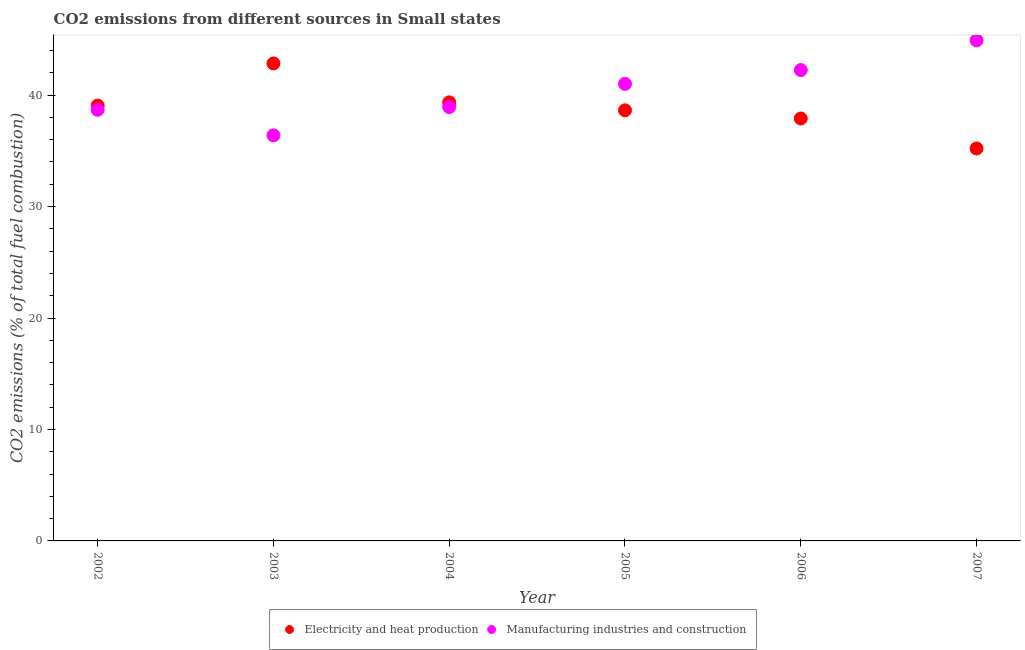What is the co2 emissions due to electricity and heat production in 2004?
Keep it short and to the point. 39.35. Across all years, what is the maximum co2 emissions due to manufacturing industries?
Offer a very short reply. 44.92. Across all years, what is the minimum co2 emissions due to manufacturing industries?
Give a very brief answer. 36.39. In which year was the co2 emissions due to manufacturing industries minimum?
Ensure brevity in your answer.  2003. What is the total co2 emissions due to manufacturing industries in the graph?
Provide a succinct answer. 242.19. What is the difference between the co2 emissions due to manufacturing industries in 2006 and that in 2007?
Keep it short and to the point. -2.67. What is the difference between the co2 emissions due to manufacturing industries in 2003 and the co2 emissions due to electricity and heat production in 2006?
Provide a short and direct response. -1.51. What is the average co2 emissions due to manufacturing industries per year?
Your answer should be very brief. 40.36. In the year 2006, what is the difference between the co2 emissions due to manufacturing industries and co2 emissions due to electricity and heat production?
Ensure brevity in your answer.  4.35. What is the ratio of the co2 emissions due to electricity and heat production in 2003 to that in 2005?
Your response must be concise. 1.11. Is the co2 emissions due to electricity and heat production in 2004 less than that in 2007?
Offer a very short reply. No. Is the difference between the co2 emissions due to manufacturing industries in 2005 and 2006 greater than the difference between the co2 emissions due to electricity and heat production in 2005 and 2006?
Give a very brief answer. No. What is the difference between the highest and the second highest co2 emissions due to electricity and heat production?
Make the answer very short. 3.49. What is the difference between the highest and the lowest co2 emissions due to electricity and heat production?
Your response must be concise. 7.63. Is the sum of the co2 emissions due to electricity and heat production in 2003 and 2004 greater than the maximum co2 emissions due to manufacturing industries across all years?
Your answer should be compact. Yes. Does the co2 emissions due to manufacturing industries monotonically increase over the years?
Provide a short and direct response. No. Is the co2 emissions due to electricity and heat production strictly less than the co2 emissions due to manufacturing industries over the years?
Provide a succinct answer. No. How many years are there in the graph?
Your answer should be very brief. 6. What is the difference between two consecutive major ticks on the Y-axis?
Keep it short and to the point. 10. Are the values on the major ticks of Y-axis written in scientific E-notation?
Provide a short and direct response. No. Does the graph contain grids?
Your answer should be compact. No. Where does the legend appear in the graph?
Make the answer very short. Bottom center. How are the legend labels stacked?
Your answer should be very brief. Horizontal. What is the title of the graph?
Offer a terse response. CO2 emissions from different sources in Small states. What is the label or title of the X-axis?
Offer a terse response. Year. What is the label or title of the Y-axis?
Give a very brief answer. CO2 emissions (% of total fuel combustion). What is the CO2 emissions (% of total fuel combustion) in Electricity and heat production in 2002?
Make the answer very short. 39.06. What is the CO2 emissions (% of total fuel combustion) in Manufacturing industries and construction in 2002?
Your answer should be compact. 38.68. What is the CO2 emissions (% of total fuel combustion) in Electricity and heat production in 2003?
Keep it short and to the point. 42.84. What is the CO2 emissions (% of total fuel combustion) in Manufacturing industries and construction in 2003?
Give a very brief answer. 36.39. What is the CO2 emissions (% of total fuel combustion) in Electricity and heat production in 2004?
Offer a very short reply. 39.35. What is the CO2 emissions (% of total fuel combustion) of Manufacturing industries and construction in 2004?
Your answer should be very brief. 38.93. What is the CO2 emissions (% of total fuel combustion) in Electricity and heat production in 2005?
Give a very brief answer. 38.64. What is the CO2 emissions (% of total fuel combustion) of Manufacturing industries and construction in 2005?
Make the answer very short. 41.01. What is the CO2 emissions (% of total fuel combustion) of Electricity and heat production in 2006?
Offer a terse response. 37.9. What is the CO2 emissions (% of total fuel combustion) in Manufacturing industries and construction in 2006?
Keep it short and to the point. 42.25. What is the CO2 emissions (% of total fuel combustion) in Electricity and heat production in 2007?
Provide a short and direct response. 35.21. What is the CO2 emissions (% of total fuel combustion) of Manufacturing industries and construction in 2007?
Your answer should be very brief. 44.92. Across all years, what is the maximum CO2 emissions (% of total fuel combustion) in Electricity and heat production?
Make the answer very short. 42.84. Across all years, what is the maximum CO2 emissions (% of total fuel combustion) of Manufacturing industries and construction?
Make the answer very short. 44.92. Across all years, what is the minimum CO2 emissions (% of total fuel combustion) of Electricity and heat production?
Make the answer very short. 35.21. Across all years, what is the minimum CO2 emissions (% of total fuel combustion) of Manufacturing industries and construction?
Your answer should be compact. 36.39. What is the total CO2 emissions (% of total fuel combustion) in Electricity and heat production in the graph?
Ensure brevity in your answer.  233.01. What is the total CO2 emissions (% of total fuel combustion) of Manufacturing industries and construction in the graph?
Make the answer very short. 242.19. What is the difference between the CO2 emissions (% of total fuel combustion) in Electricity and heat production in 2002 and that in 2003?
Your answer should be compact. -3.78. What is the difference between the CO2 emissions (% of total fuel combustion) of Manufacturing industries and construction in 2002 and that in 2003?
Your answer should be compact. 2.3. What is the difference between the CO2 emissions (% of total fuel combustion) in Electricity and heat production in 2002 and that in 2004?
Keep it short and to the point. -0.29. What is the difference between the CO2 emissions (% of total fuel combustion) of Manufacturing industries and construction in 2002 and that in 2004?
Provide a short and direct response. -0.25. What is the difference between the CO2 emissions (% of total fuel combustion) in Electricity and heat production in 2002 and that in 2005?
Your answer should be very brief. 0.42. What is the difference between the CO2 emissions (% of total fuel combustion) of Manufacturing industries and construction in 2002 and that in 2005?
Give a very brief answer. -2.33. What is the difference between the CO2 emissions (% of total fuel combustion) in Electricity and heat production in 2002 and that in 2006?
Ensure brevity in your answer.  1.16. What is the difference between the CO2 emissions (% of total fuel combustion) in Manufacturing industries and construction in 2002 and that in 2006?
Offer a terse response. -3.56. What is the difference between the CO2 emissions (% of total fuel combustion) of Electricity and heat production in 2002 and that in 2007?
Provide a succinct answer. 3.85. What is the difference between the CO2 emissions (% of total fuel combustion) in Manufacturing industries and construction in 2002 and that in 2007?
Offer a very short reply. -6.24. What is the difference between the CO2 emissions (% of total fuel combustion) of Electricity and heat production in 2003 and that in 2004?
Offer a terse response. 3.49. What is the difference between the CO2 emissions (% of total fuel combustion) of Manufacturing industries and construction in 2003 and that in 2004?
Make the answer very short. -2.54. What is the difference between the CO2 emissions (% of total fuel combustion) of Electricity and heat production in 2003 and that in 2005?
Make the answer very short. 4.21. What is the difference between the CO2 emissions (% of total fuel combustion) of Manufacturing industries and construction in 2003 and that in 2005?
Offer a terse response. -4.62. What is the difference between the CO2 emissions (% of total fuel combustion) of Electricity and heat production in 2003 and that in 2006?
Give a very brief answer. 4.94. What is the difference between the CO2 emissions (% of total fuel combustion) in Manufacturing industries and construction in 2003 and that in 2006?
Offer a very short reply. -5.86. What is the difference between the CO2 emissions (% of total fuel combustion) of Electricity and heat production in 2003 and that in 2007?
Provide a short and direct response. 7.63. What is the difference between the CO2 emissions (% of total fuel combustion) in Manufacturing industries and construction in 2003 and that in 2007?
Provide a short and direct response. -8.53. What is the difference between the CO2 emissions (% of total fuel combustion) in Manufacturing industries and construction in 2004 and that in 2005?
Your answer should be very brief. -2.08. What is the difference between the CO2 emissions (% of total fuel combustion) of Electricity and heat production in 2004 and that in 2006?
Your answer should be compact. 1.45. What is the difference between the CO2 emissions (% of total fuel combustion) of Manufacturing industries and construction in 2004 and that in 2006?
Ensure brevity in your answer.  -3.32. What is the difference between the CO2 emissions (% of total fuel combustion) of Electricity and heat production in 2004 and that in 2007?
Your answer should be compact. 4.14. What is the difference between the CO2 emissions (% of total fuel combustion) of Manufacturing industries and construction in 2004 and that in 2007?
Offer a very short reply. -5.99. What is the difference between the CO2 emissions (% of total fuel combustion) in Electricity and heat production in 2005 and that in 2006?
Your answer should be compact. 0.73. What is the difference between the CO2 emissions (% of total fuel combustion) of Manufacturing industries and construction in 2005 and that in 2006?
Ensure brevity in your answer.  -1.24. What is the difference between the CO2 emissions (% of total fuel combustion) in Electricity and heat production in 2005 and that in 2007?
Your answer should be compact. 3.42. What is the difference between the CO2 emissions (% of total fuel combustion) in Manufacturing industries and construction in 2005 and that in 2007?
Give a very brief answer. -3.91. What is the difference between the CO2 emissions (% of total fuel combustion) in Electricity and heat production in 2006 and that in 2007?
Provide a succinct answer. 2.69. What is the difference between the CO2 emissions (% of total fuel combustion) of Manufacturing industries and construction in 2006 and that in 2007?
Your answer should be very brief. -2.67. What is the difference between the CO2 emissions (% of total fuel combustion) of Electricity and heat production in 2002 and the CO2 emissions (% of total fuel combustion) of Manufacturing industries and construction in 2003?
Ensure brevity in your answer.  2.67. What is the difference between the CO2 emissions (% of total fuel combustion) of Electricity and heat production in 2002 and the CO2 emissions (% of total fuel combustion) of Manufacturing industries and construction in 2004?
Your answer should be very brief. 0.13. What is the difference between the CO2 emissions (% of total fuel combustion) in Electricity and heat production in 2002 and the CO2 emissions (% of total fuel combustion) in Manufacturing industries and construction in 2005?
Your answer should be very brief. -1.95. What is the difference between the CO2 emissions (% of total fuel combustion) of Electricity and heat production in 2002 and the CO2 emissions (% of total fuel combustion) of Manufacturing industries and construction in 2006?
Provide a succinct answer. -3.19. What is the difference between the CO2 emissions (% of total fuel combustion) in Electricity and heat production in 2002 and the CO2 emissions (% of total fuel combustion) in Manufacturing industries and construction in 2007?
Provide a short and direct response. -5.86. What is the difference between the CO2 emissions (% of total fuel combustion) of Electricity and heat production in 2003 and the CO2 emissions (% of total fuel combustion) of Manufacturing industries and construction in 2004?
Provide a short and direct response. 3.91. What is the difference between the CO2 emissions (% of total fuel combustion) in Electricity and heat production in 2003 and the CO2 emissions (% of total fuel combustion) in Manufacturing industries and construction in 2005?
Ensure brevity in your answer.  1.83. What is the difference between the CO2 emissions (% of total fuel combustion) of Electricity and heat production in 2003 and the CO2 emissions (% of total fuel combustion) of Manufacturing industries and construction in 2006?
Your answer should be compact. 0.6. What is the difference between the CO2 emissions (% of total fuel combustion) of Electricity and heat production in 2003 and the CO2 emissions (% of total fuel combustion) of Manufacturing industries and construction in 2007?
Your answer should be compact. -2.08. What is the difference between the CO2 emissions (% of total fuel combustion) in Electricity and heat production in 2004 and the CO2 emissions (% of total fuel combustion) in Manufacturing industries and construction in 2005?
Your answer should be very brief. -1.66. What is the difference between the CO2 emissions (% of total fuel combustion) of Electricity and heat production in 2004 and the CO2 emissions (% of total fuel combustion) of Manufacturing industries and construction in 2006?
Your answer should be very brief. -2.9. What is the difference between the CO2 emissions (% of total fuel combustion) in Electricity and heat production in 2004 and the CO2 emissions (% of total fuel combustion) in Manufacturing industries and construction in 2007?
Ensure brevity in your answer.  -5.57. What is the difference between the CO2 emissions (% of total fuel combustion) in Electricity and heat production in 2005 and the CO2 emissions (% of total fuel combustion) in Manufacturing industries and construction in 2006?
Make the answer very short. -3.61. What is the difference between the CO2 emissions (% of total fuel combustion) in Electricity and heat production in 2005 and the CO2 emissions (% of total fuel combustion) in Manufacturing industries and construction in 2007?
Provide a short and direct response. -6.28. What is the difference between the CO2 emissions (% of total fuel combustion) in Electricity and heat production in 2006 and the CO2 emissions (% of total fuel combustion) in Manufacturing industries and construction in 2007?
Ensure brevity in your answer.  -7.02. What is the average CO2 emissions (% of total fuel combustion) of Electricity and heat production per year?
Your answer should be very brief. 38.84. What is the average CO2 emissions (% of total fuel combustion) of Manufacturing industries and construction per year?
Your response must be concise. 40.36. In the year 2002, what is the difference between the CO2 emissions (% of total fuel combustion) of Electricity and heat production and CO2 emissions (% of total fuel combustion) of Manufacturing industries and construction?
Your response must be concise. 0.38. In the year 2003, what is the difference between the CO2 emissions (% of total fuel combustion) of Electricity and heat production and CO2 emissions (% of total fuel combustion) of Manufacturing industries and construction?
Ensure brevity in your answer.  6.46. In the year 2004, what is the difference between the CO2 emissions (% of total fuel combustion) in Electricity and heat production and CO2 emissions (% of total fuel combustion) in Manufacturing industries and construction?
Offer a terse response. 0.42. In the year 2005, what is the difference between the CO2 emissions (% of total fuel combustion) in Electricity and heat production and CO2 emissions (% of total fuel combustion) in Manufacturing industries and construction?
Your answer should be very brief. -2.38. In the year 2006, what is the difference between the CO2 emissions (% of total fuel combustion) of Electricity and heat production and CO2 emissions (% of total fuel combustion) of Manufacturing industries and construction?
Your response must be concise. -4.35. In the year 2007, what is the difference between the CO2 emissions (% of total fuel combustion) of Electricity and heat production and CO2 emissions (% of total fuel combustion) of Manufacturing industries and construction?
Your response must be concise. -9.71. What is the ratio of the CO2 emissions (% of total fuel combustion) in Electricity and heat production in 2002 to that in 2003?
Provide a short and direct response. 0.91. What is the ratio of the CO2 emissions (% of total fuel combustion) of Manufacturing industries and construction in 2002 to that in 2003?
Your answer should be very brief. 1.06. What is the ratio of the CO2 emissions (% of total fuel combustion) in Electricity and heat production in 2002 to that in 2004?
Your answer should be very brief. 0.99. What is the ratio of the CO2 emissions (% of total fuel combustion) of Electricity and heat production in 2002 to that in 2005?
Your response must be concise. 1.01. What is the ratio of the CO2 emissions (% of total fuel combustion) in Manufacturing industries and construction in 2002 to that in 2005?
Keep it short and to the point. 0.94. What is the ratio of the CO2 emissions (% of total fuel combustion) of Electricity and heat production in 2002 to that in 2006?
Your answer should be compact. 1.03. What is the ratio of the CO2 emissions (% of total fuel combustion) in Manufacturing industries and construction in 2002 to that in 2006?
Provide a succinct answer. 0.92. What is the ratio of the CO2 emissions (% of total fuel combustion) in Electricity and heat production in 2002 to that in 2007?
Give a very brief answer. 1.11. What is the ratio of the CO2 emissions (% of total fuel combustion) in Manufacturing industries and construction in 2002 to that in 2007?
Offer a very short reply. 0.86. What is the ratio of the CO2 emissions (% of total fuel combustion) in Electricity and heat production in 2003 to that in 2004?
Make the answer very short. 1.09. What is the ratio of the CO2 emissions (% of total fuel combustion) of Manufacturing industries and construction in 2003 to that in 2004?
Provide a short and direct response. 0.93. What is the ratio of the CO2 emissions (% of total fuel combustion) of Electricity and heat production in 2003 to that in 2005?
Give a very brief answer. 1.11. What is the ratio of the CO2 emissions (% of total fuel combustion) of Manufacturing industries and construction in 2003 to that in 2005?
Your answer should be very brief. 0.89. What is the ratio of the CO2 emissions (% of total fuel combustion) of Electricity and heat production in 2003 to that in 2006?
Your answer should be compact. 1.13. What is the ratio of the CO2 emissions (% of total fuel combustion) in Manufacturing industries and construction in 2003 to that in 2006?
Ensure brevity in your answer.  0.86. What is the ratio of the CO2 emissions (% of total fuel combustion) of Electricity and heat production in 2003 to that in 2007?
Your response must be concise. 1.22. What is the ratio of the CO2 emissions (% of total fuel combustion) in Manufacturing industries and construction in 2003 to that in 2007?
Make the answer very short. 0.81. What is the ratio of the CO2 emissions (% of total fuel combustion) in Electricity and heat production in 2004 to that in 2005?
Your answer should be compact. 1.02. What is the ratio of the CO2 emissions (% of total fuel combustion) in Manufacturing industries and construction in 2004 to that in 2005?
Make the answer very short. 0.95. What is the ratio of the CO2 emissions (% of total fuel combustion) of Electricity and heat production in 2004 to that in 2006?
Your response must be concise. 1.04. What is the ratio of the CO2 emissions (% of total fuel combustion) in Manufacturing industries and construction in 2004 to that in 2006?
Your answer should be very brief. 0.92. What is the ratio of the CO2 emissions (% of total fuel combustion) of Electricity and heat production in 2004 to that in 2007?
Make the answer very short. 1.12. What is the ratio of the CO2 emissions (% of total fuel combustion) in Manufacturing industries and construction in 2004 to that in 2007?
Keep it short and to the point. 0.87. What is the ratio of the CO2 emissions (% of total fuel combustion) of Electricity and heat production in 2005 to that in 2006?
Your answer should be very brief. 1.02. What is the ratio of the CO2 emissions (% of total fuel combustion) in Manufacturing industries and construction in 2005 to that in 2006?
Provide a short and direct response. 0.97. What is the ratio of the CO2 emissions (% of total fuel combustion) of Electricity and heat production in 2005 to that in 2007?
Keep it short and to the point. 1.1. What is the ratio of the CO2 emissions (% of total fuel combustion) of Manufacturing industries and construction in 2005 to that in 2007?
Make the answer very short. 0.91. What is the ratio of the CO2 emissions (% of total fuel combustion) of Electricity and heat production in 2006 to that in 2007?
Keep it short and to the point. 1.08. What is the ratio of the CO2 emissions (% of total fuel combustion) in Manufacturing industries and construction in 2006 to that in 2007?
Your answer should be compact. 0.94. What is the difference between the highest and the second highest CO2 emissions (% of total fuel combustion) in Electricity and heat production?
Your answer should be very brief. 3.49. What is the difference between the highest and the second highest CO2 emissions (% of total fuel combustion) in Manufacturing industries and construction?
Make the answer very short. 2.67. What is the difference between the highest and the lowest CO2 emissions (% of total fuel combustion) of Electricity and heat production?
Offer a very short reply. 7.63. What is the difference between the highest and the lowest CO2 emissions (% of total fuel combustion) in Manufacturing industries and construction?
Offer a terse response. 8.53. 